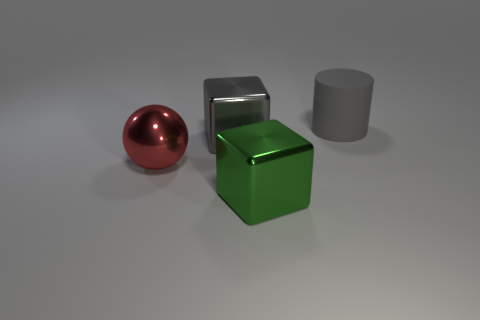Is there any other thing that is the same material as the big cylinder?
Keep it short and to the point. No. What number of large matte cylinders have the same color as the rubber object?
Provide a succinct answer. 0. How many objects are either objects on the left side of the cylinder or large balls?
Offer a terse response. 3. There is another cube that is made of the same material as the large gray cube; what color is it?
Give a very brief answer. Green. Are there any red spheres of the same size as the green metal thing?
Offer a very short reply. Yes. How many objects are either blocks left of the large green cube or shiny things behind the large shiny sphere?
Give a very brief answer. 1. What is the shape of the green shiny object that is the same size as the red metal object?
Ensure brevity in your answer.  Cube. Are there any other large red metal objects of the same shape as the red shiny object?
Offer a terse response. No. Is the number of gray rubber cylinders less than the number of cyan spheres?
Ensure brevity in your answer.  No. There is a cube on the left side of the green block; is it the same size as the thing that is in front of the red object?
Your answer should be compact. Yes. 